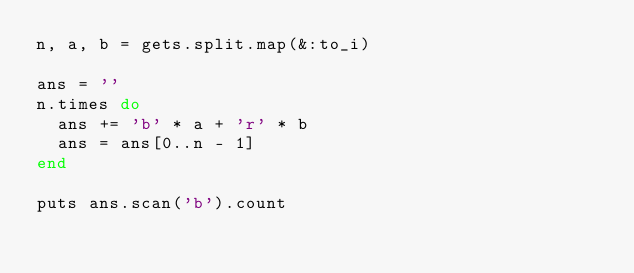<code> <loc_0><loc_0><loc_500><loc_500><_Ruby_>n, a, b = gets.split.map(&:to_i)

ans = ''
n.times do
  ans += 'b' * a + 'r' * b
  ans = ans[0..n - 1]
end

puts ans.scan('b').count
</code> 